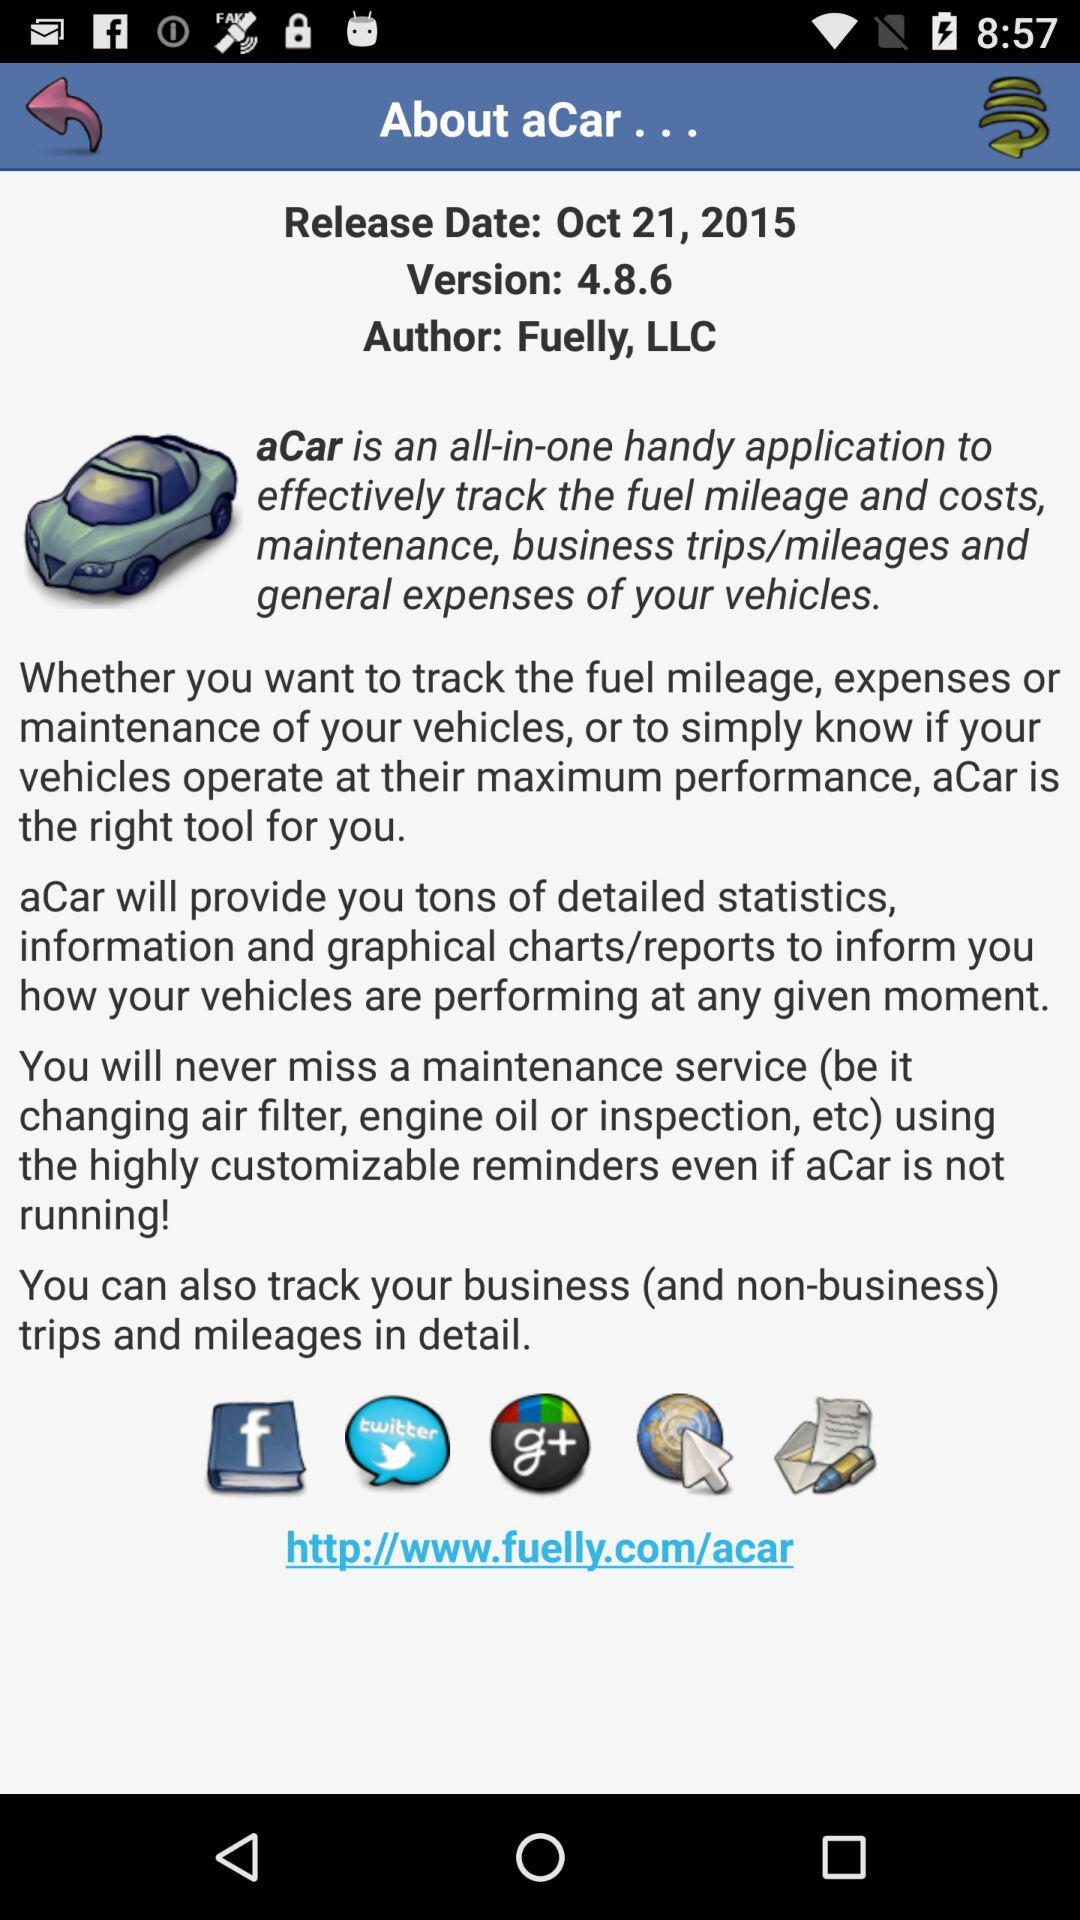Who is the author? The author is "Fuelly, LLC". 